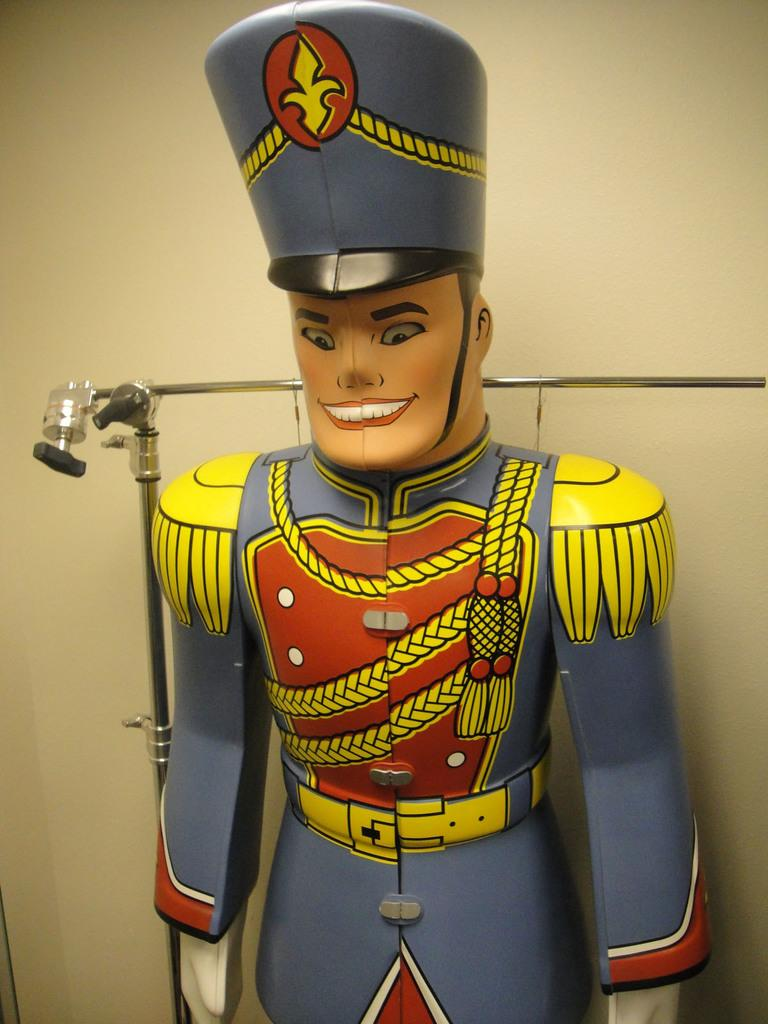What type of object is in the image? There is a toy person in the image. What is the toy person wearing? The toy person is wearing a dress with gray, yellow, and red colors. What can be seen in the background of the image? There is a rod visible in the background of the image. What color is the wall in the background? The wall in the background is cream-colored. What type of thunder can be heard in the image? There is no sound present in the image, so it is not possible to hear any thunder. 